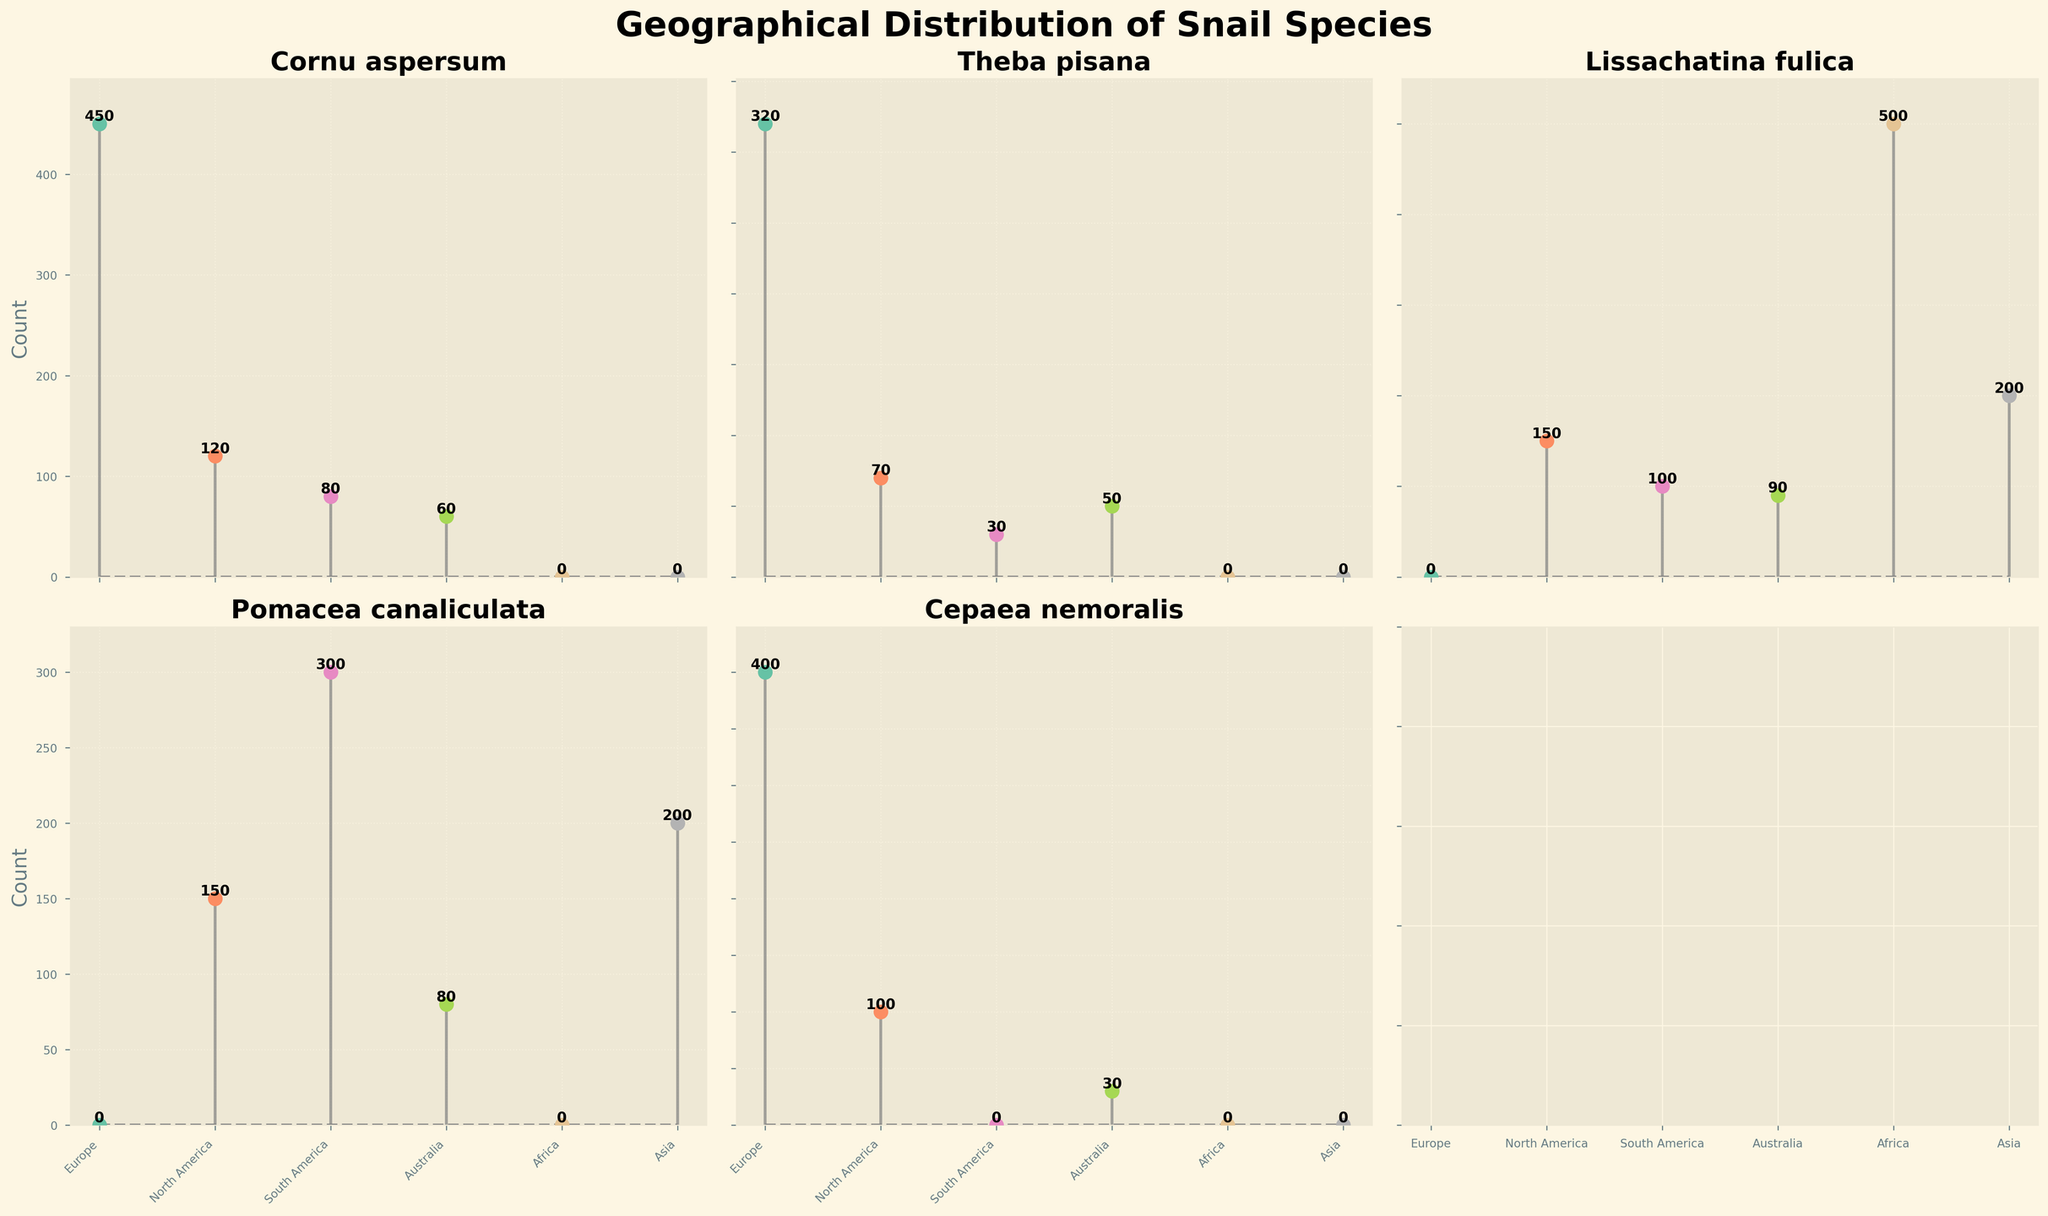What is the title of the figure? The title of the figure is written at the top, in a bold and large font.
Answer: Geographical Distribution of Snail Species How many continents are displayed in each subplot? Each subplot represents different snail species with their counts in various continents, and the continents are specified on the x-axis labels.
Answer: 5 Which species has the highest count in Africa? Locating the subplot for each species and identifying the bar with the label "Africa," Lissachatina fulica shows the highest count in Africa.
Answer: Lissachatina fulica How many total snails are there of the species Cornu aspersum? Sum the counts for Cornu aspersum from each continent's y-values: 450 (Europe) + 120 (North America) + 80 (South America) + 60 (Australia).
Answer: 710 Which continent has the least number of Theba pisana? Check the counts for Theba pisana across continents and identify the smallest one, which is South America.
Answer: South America Compare the count of Lissachatina fulica in North America with that in Europe. Which one is greater and by how much? Look for the respective y-values of Lissachatina fulica in North America (150) and Europe (N/A), noting that Europe is not listed for this species. Therefore, North America by default is greater.
Answer: North America, 150 What is the median count of snails for Pomacea canaliculata across all displayed continents? Arrange the counts: 300 (South America), 200 (Asia), 150 (North America), 80 (Australia). Since the number of data points is even, the median is the average of the middle two values: (200 + 150) / 2.
Answer: 175 Which species has the most uniform distribution across all continents? Observing the counts across continents for each species, Theba pisana and Pomacea canaliculata have relatively uniform distributions compared to others.
Answer: Theba pisana, Pomacea canaliculata How many more snails of Cepaea nemoralis are there in Europe compared to Australia? Subtract the count of snails in Australia from the count in Europe for Cepaea nemoralis: 400 (Europe) - 30 (Australia).
Answer: 370 